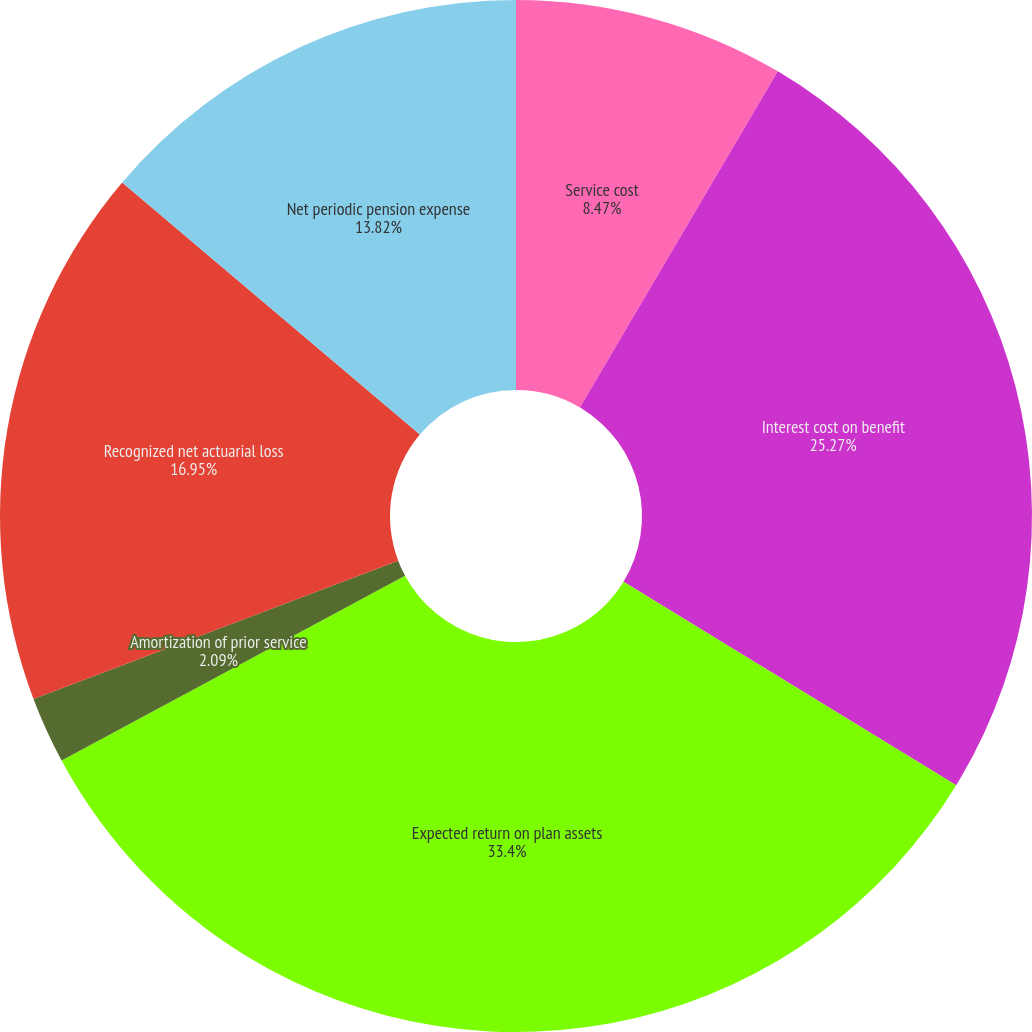Convert chart to OTSL. <chart><loc_0><loc_0><loc_500><loc_500><pie_chart><fcel>Service cost<fcel>Interest cost on benefit<fcel>Expected return on plan assets<fcel>Amortization of prior service<fcel>Recognized net actuarial loss<fcel>Net periodic pension expense<nl><fcel>8.47%<fcel>25.27%<fcel>33.41%<fcel>2.09%<fcel>16.95%<fcel>13.82%<nl></chart> 